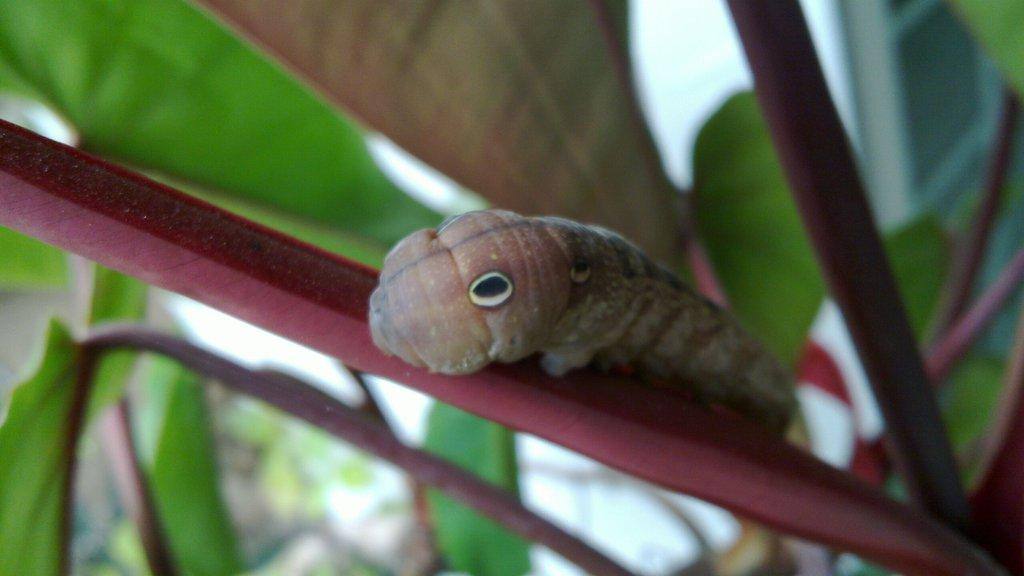What is the main subject of the image? There is a caterpillar in the image. Where is the caterpillar located? The caterpillar is on a leaf. What is the leaf a part of? The leaf belongs to a plant. What type of crown is the caterpillar wearing in the image? There is no crown present in the image; the caterpillar is simply on a leaf. 